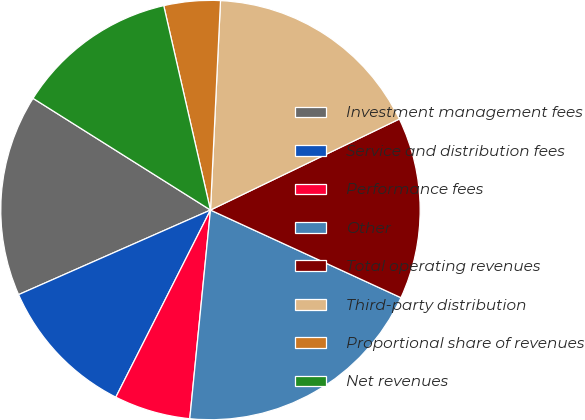Convert chart to OTSL. <chart><loc_0><loc_0><loc_500><loc_500><pie_chart><fcel>Investment management fees<fcel>Service and distribution fees<fcel>Performance fees<fcel>Other<fcel>Total operating revenues<fcel>Third-party distribution<fcel>Proportional share of revenues<fcel>Net revenues<nl><fcel>15.55%<fcel>10.94%<fcel>5.88%<fcel>19.71%<fcel>14.01%<fcel>17.09%<fcel>4.34%<fcel>12.48%<nl></chart> 